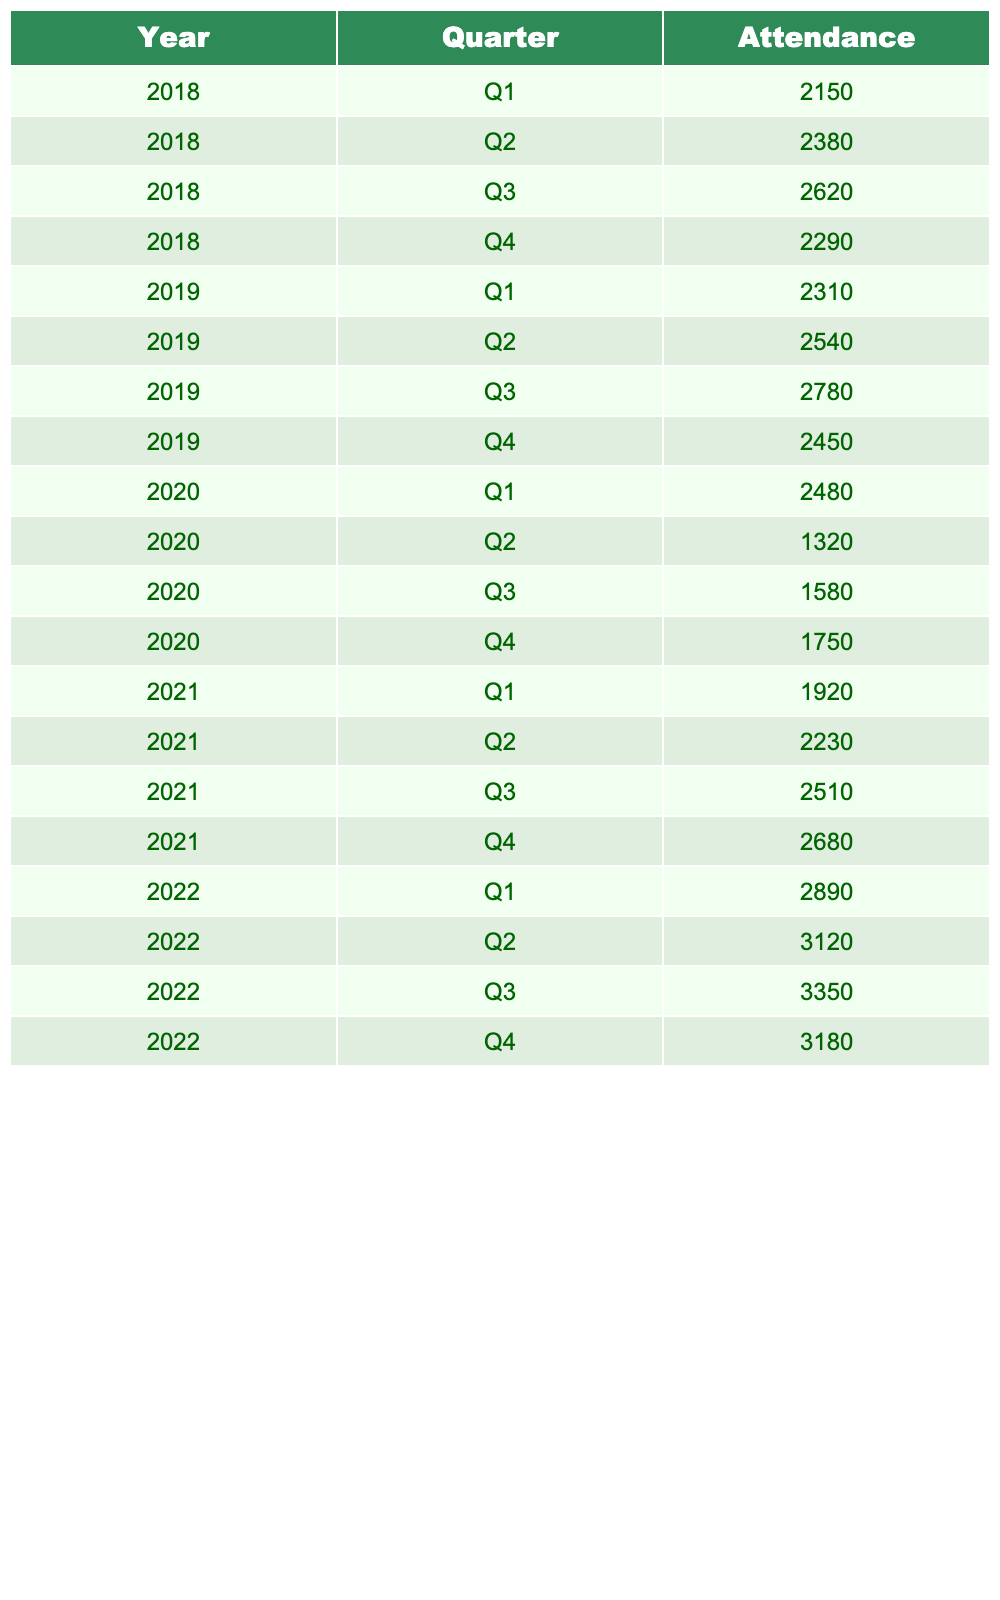What was the total attendance in Q2 of 2021? In Q2 of 2021, the attendance was 2230.
Answer: 2230 What was the highest attendance recorded in 2022? The attendance figures for 2022 are: Q1 (2890), Q2 (3120), Q3 (3350), and Q4 (3180). The highest value is in Q3 at 3350.
Answer: 3350 What is the attendance for Q4 in 2019? The attendance for Q4 in 2019 is listed as 2450.
Answer: 2450 Which quarter in 2020 had the lowest attendance? The attendance figures for 2020 are: Q1 (2480), Q2 (1320), Q3 (1580), and Q4 (1750). Q2 has the lowest attendance at 1320.
Answer: Q2 What was the average attendance over the four quarters of 2021? The attendance figures for 2021 are: Q1 (1920), Q2 (2230), Q3 (2510), and Q4 (2680). The total attendance is 1920 + 2230 + 2510 + 2680 = 9340. Dividing by 4 gives an average of 2335.
Answer: 2335 Was attendance higher in Q3 2019 compared to Q1 2020? Attendance for Q3 2019 was 2780, while attendance for Q1 2020 was 2480. Since 2780 is greater than 2480, attendance was higher in Q3 2019.
Answer: Yes What is the total attendance from all quarters in 2018? The attendance for 2018 is: Q1 (2150), Q2 (2380), Q3 (2620), and Q4 (2290). Adding these values gives 2150 + 2380 + 2620 + 2290 = 9440.
Answer: 9440 In which year did the attendance first exceed 3000? The attendance figures are 2890 in Q1 and 3120 in Q2 of 2022. Thus, attendance first exceeded 3000 in 2022 with Q2.
Answer: 2022 What is the difference in attendance from Q1 2019 to Q1 2022? Attendance for Q1 2019 is 2310, and for Q1 2022 it is 2890. The difference is 2890 - 2310 = 580.
Answer: 580 Was there a decline in attendance from Q3 to Q4 in 2020? Q3 attendance for 2020 is 1580 and Q4 is 1750. Since 1750 is greater than 1580, there was no decline.
Answer: No Which quarter had the highest attendance in 2018? The quarter attendance in 2018 is: Q1 (2150), Q2 (2380), Q3 (2620), Q4 (2290). The highest is Q3 with 2620.
Answer: Q3 